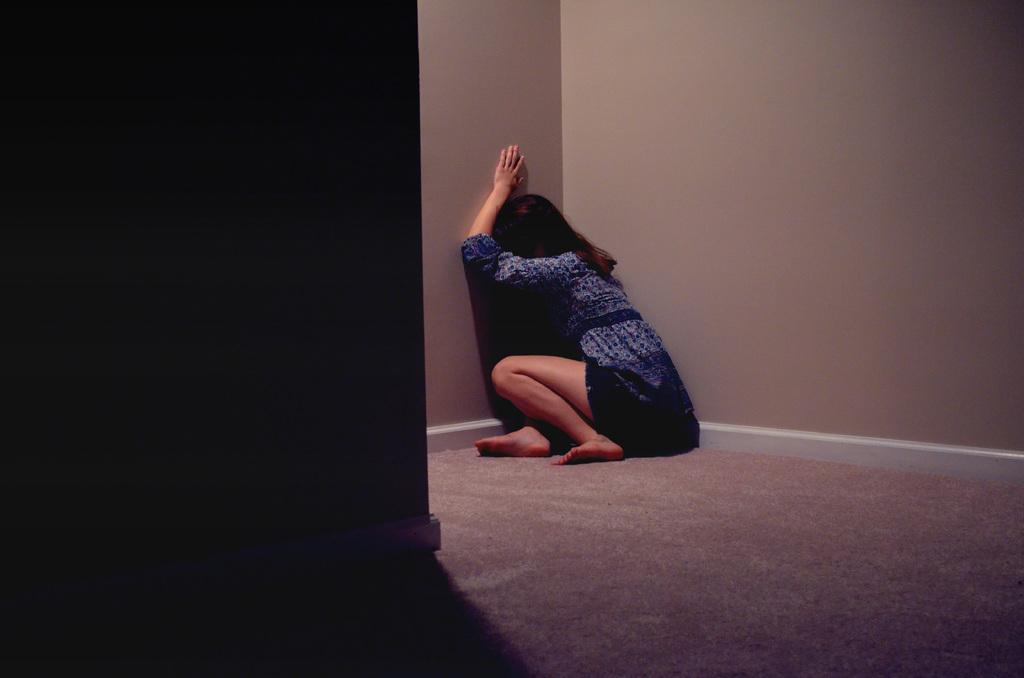What is the woman doing in the image? The woman is seated on the floor in the image. What is on the floor beneath the woman? There is a carpet on the floor in the image. What can be seen surrounding the woman? Walls are visible in the image. What type of flowers can be seen in the park in the image? There is no park or flowers present in the image; it features a woman seated on a carpet with walls visible. 